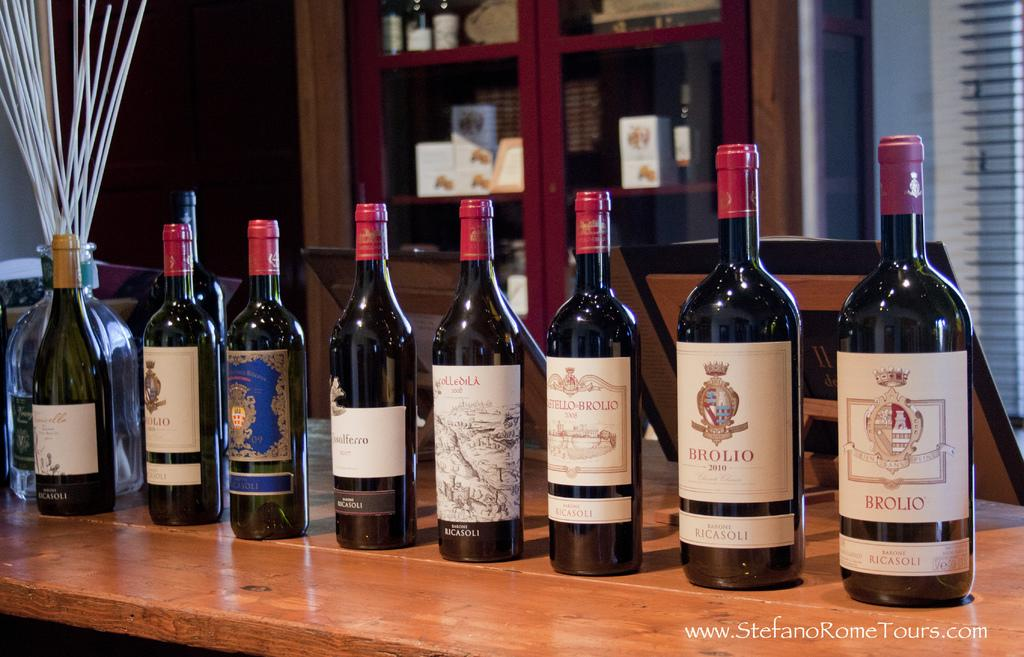<image>
Provide a brief description of the given image. the word Brolio that is on the front of a bottle 